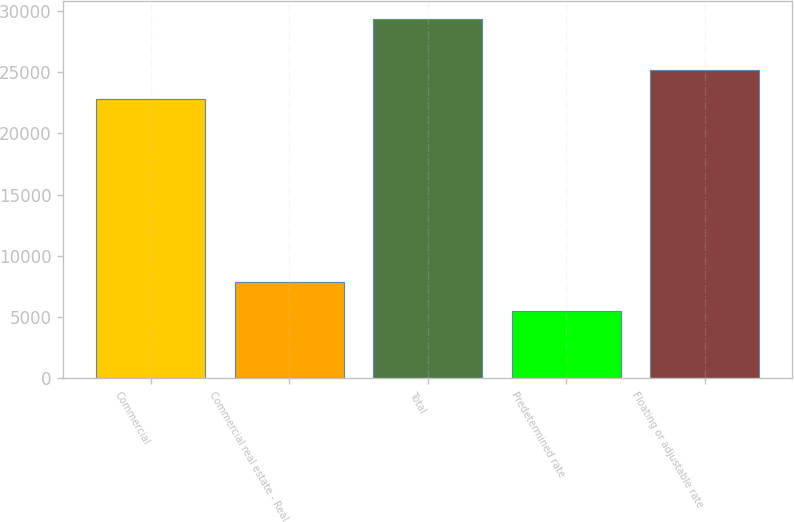Convert chart. <chart><loc_0><loc_0><loc_500><loc_500><bar_chart><fcel>Commercial<fcel>Commercial real estate - Real<fcel>Total<fcel>Predetermined rate<fcel>Floating or adjustable rate<nl><fcel>22804<fcel>7850.1<fcel>29379<fcel>5458<fcel>25196.1<nl></chart> 